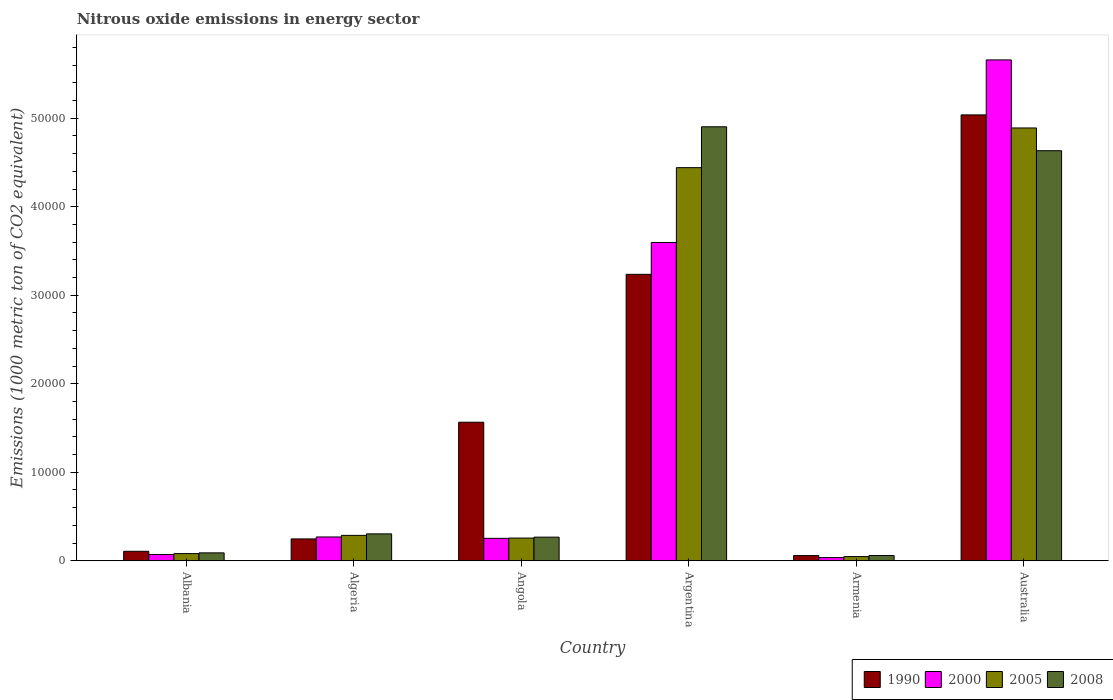How many different coloured bars are there?
Provide a short and direct response. 4. How many groups of bars are there?
Offer a terse response. 6. Are the number of bars per tick equal to the number of legend labels?
Offer a very short reply. Yes. How many bars are there on the 5th tick from the left?
Make the answer very short. 4. What is the label of the 6th group of bars from the left?
Keep it short and to the point. Australia. In how many cases, is the number of bars for a given country not equal to the number of legend labels?
Your answer should be compact. 0. What is the amount of nitrous oxide emitted in 2005 in Algeria?
Keep it short and to the point. 2868.2. Across all countries, what is the maximum amount of nitrous oxide emitted in 2008?
Your answer should be compact. 4.90e+04. Across all countries, what is the minimum amount of nitrous oxide emitted in 2008?
Keep it short and to the point. 593.5. In which country was the amount of nitrous oxide emitted in 2000 maximum?
Offer a very short reply. Australia. In which country was the amount of nitrous oxide emitted in 2000 minimum?
Your answer should be very brief. Armenia. What is the total amount of nitrous oxide emitted in 2005 in the graph?
Your response must be concise. 1.00e+05. What is the difference between the amount of nitrous oxide emitted in 2008 in Angola and that in Australia?
Provide a short and direct response. -4.37e+04. What is the difference between the amount of nitrous oxide emitted in 1990 in Argentina and the amount of nitrous oxide emitted in 2008 in Australia?
Offer a terse response. -1.40e+04. What is the average amount of nitrous oxide emitted in 1990 per country?
Make the answer very short. 1.71e+04. What is the difference between the amount of nitrous oxide emitted of/in 2005 and amount of nitrous oxide emitted of/in 1990 in Albania?
Your response must be concise. -259.9. In how many countries, is the amount of nitrous oxide emitted in 1990 greater than 14000 1000 metric ton?
Your response must be concise. 3. What is the ratio of the amount of nitrous oxide emitted in 1990 in Albania to that in Argentina?
Keep it short and to the point. 0.03. Is the amount of nitrous oxide emitted in 2005 in Algeria less than that in Armenia?
Make the answer very short. No. Is the difference between the amount of nitrous oxide emitted in 2005 in Albania and Australia greater than the difference between the amount of nitrous oxide emitted in 1990 in Albania and Australia?
Keep it short and to the point. Yes. What is the difference between the highest and the second highest amount of nitrous oxide emitted in 2008?
Offer a terse response. -4.60e+04. What is the difference between the highest and the lowest amount of nitrous oxide emitted in 2008?
Your response must be concise. 4.84e+04. What does the 2nd bar from the right in Angola represents?
Provide a succinct answer. 2005. Is it the case that in every country, the sum of the amount of nitrous oxide emitted in 1990 and amount of nitrous oxide emitted in 2008 is greater than the amount of nitrous oxide emitted in 2000?
Your answer should be compact. Yes. How many bars are there?
Provide a succinct answer. 24. How many countries are there in the graph?
Your answer should be compact. 6. Does the graph contain any zero values?
Make the answer very short. No. Does the graph contain grids?
Your answer should be very brief. No. Where does the legend appear in the graph?
Give a very brief answer. Bottom right. How many legend labels are there?
Make the answer very short. 4. How are the legend labels stacked?
Offer a very short reply. Horizontal. What is the title of the graph?
Offer a terse response. Nitrous oxide emissions in energy sector. Does "1987" appear as one of the legend labels in the graph?
Offer a very short reply. No. What is the label or title of the Y-axis?
Give a very brief answer. Emissions (1000 metric ton of CO2 equivalent). What is the Emissions (1000 metric ton of CO2 equivalent) in 1990 in Albania?
Make the answer very short. 1071.9. What is the Emissions (1000 metric ton of CO2 equivalent) in 2000 in Albania?
Keep it short and to the point. 712.1. What is the Emissions (1000 metric ton of CO2 equivalent) of 2005 in Albania?
Your response must be concise. 812. What is the Emissions (1000 metric ton of CO2 equivalent) in 2008 in Albania?
Your answer should be very brief. 894. What is the Emissions (1000 metric ton of CO2 equivalent) in 1990 in Algeria?
Your answer should be compact. 2469.5. What is the Emissions (1000 metric ton of CO2 equivalent) in 2000 in Algeria?
Provide a succinct answer. 2690.4. What is the Emissions (1000 metric ton of CO2 equivalent) of 2005 in Algeria?
Provide a short and direct response. 2868.2. What is the Emissions (1000 metric ton of CO2 equivalent) of 2008 in Algeria?
Your answer should be very brief. 3040.1. What is the Emissions (1000 metric ton of CO2 equivalent) in 1990 in Angola?
Keep it short and to the point. 1.57e+04. What is the Emissions (1000 metric ton of CO2 equivalent) of 2000 in Angola?
Keep it short and to the point. 2535.2. What is the Emissions (1000 metric ton of CO2 equivalent) of 2005 in Angola?
Make the answer very short. 2567.4. What is the Emissions (1000 metric ton of CO2 equivalent) in 2008 in Angola?
Give a very brief answer. 2670.3. What is the Emissions (1000 metric ton of CO2 equivalent) in 1990 in Argentina?
Give a very brief answer. 3.24e+04. What is the Emissions (1000 metric ton of CO2 equivalent) of 2000 in Argentina?
Give a very brief answer. 3.60e+04. What is the Emissions (1000 metric ton of CO2 equivalent) in 2005 in Argentina?
Keep it short and to the point. 4.44e+04. What is the Emissions (1000 metric ton of CO2 equivalent) in 2008 in Argentina?
Your response must be concise. 4.90e+04. What is the Emissions (1000 metric ton of CO2 equivalent) of 1990 in Armenia?
Offer a terse response. 586.2. What is the Emissions (1000 metric ton of CO2 equivalent) of 2000 in Armenia?
Provide a short and direct response. 356.1. What is the Emissions (1000 metric ton of CO2 equivalent) in 2005 in Armenia?
Give a very brief answer. 473.3. What is the Emissions (1000 metric ton of CO2 equivalent) in 2008 in Armenia?
Ensure brevity in your answer.  593.5. What is the Emissions (1000 metric ton of CO2 equivalent) of 1990 in Australia?
Give a very brief answer. 5.04e+04. What is the Emissions (1000 metric ton of CO2 equivalent) in 2000 in Australia?
Keep it short and to the point. 5.66e+04. What is the Emissions (1000 metric ton of CO2 equivalent) in 2005 in Australia?
Ensure brevity in your answer.  4.89e+04. What is the Emissions (1000 metric ton of CO2 equivalent) of 2008 in Australia?
Make the answer very short. 4.63e+04. Across all countries, what is the maximum Emissions (1000 metric ton of CO2 equivalent) of 1990?
Offer a terse response. 5.04e+04. Across all countries, what is the maximum Emissions (1000 metric ton of CO2 equivalent) of 2000?
Your response must be concise. 5.66e+04. Across all countries, what is the maximum Emissions (1000 metric ton of CO2 equivalent) of 2005?
Make the answer very short. 4.89e+04. Across all countries, what is the maximum Emissions (1000 metric ton of CO2 equivalent) in 2008?
Offer a terse response. 4.90e+04. Across all countries, what is the minimum Emissions (1000 metric ton of CO2 equivalent) of 1990?
Your response must be concise. 586.2. Across all countries, what is the minimum Emissions (1000 metric ton of CO2 equivalent) in 2000?
Keep it short and to the point. 356.1. Across all countries, what is the minimum Emissions (1000 metric ton of CO2 equivalent) of 2005?
Offer a terse response. 473.3. Across all countries, what is the minimum Emissions (1000 metric ton of CO2 equivalent) of 2008?
Provide a short and direct response. 593.5. What is the total Emissions (1000 metric ton of CO2 equivalent) in 1990 in the graph?
Ensure brevity in your answer.  1.03e+05. What is the total Emissions (1000 metric ton of CO2 equivalent) of 2000 in the graph?
Provide a succinct answer. 9.88e+04. What is the total Emissions (1000 metric ton of CO2 equivalent) in 2005 in the graph?
Your answer should be compact. 1.00e+05. What is the total Emissions (1000 metric ton of CO2 equivalent) in 2008 in the graph?
Your response must be concise. 1.03e+05. What is the difference between the Emissions (1000 metric ton of CO2 equivalent) in 1990 in Albania and that in Algeria?
Give a very brief answer. -1397.6. What is the difference between the Emissions (1000 metric ton of CO2 equivalent) in 2000 in Albania and that in Algeria?
Your answer should be very brief. -1978.3. What is the difference between the Emissions (1000 metric ton of CO2 equivalent) of 2005 in Albania and that in Algeria?
Ensure brevity in your answer.  -2056.2. What is the difference between the Emissions (1000 metric ton of CO2 equivalent) in 2008 in Albania and that in Algeria?
Give a very brief answer. -2146.1. What is the difference between the Emissions (1000 metric ton of CO2 equivalent) of 1990 in Albania and that in Angola?
Make the answer very short. -1.46e+04. What is the difference between the Emissions (1000 metric ton of CO2 equivalent) in 2000 in Albania and that in Angola?
Give a very brief answer. -1823.1. What is the difference between the Emissions (1000 metric ton of CO2 equivalent) of 2005 in Albania and that in Angola?
Offer a terse response. -1755.4. What is the difference between the Emissions (1000 metric ton of CO2 equivalent) in 2008 in Albania and that in Angola?
Your answer should be very brief. -1776.3. What is the difference between the Emissions (1000 metric ton of CO2 equivalent) in 1990 in Albania and that in Argentina?
Your answer should be very brief. -3.13e+04. What is the difference between the Emissions (1000 metric ton of CO2 equivalent) in 2000 in Albania and that in Argentina?
Your answer should be very brief. -3.53e+04. What is the difference between the Emissions (1000 metric ton of CO2 equivalent) in 2005 in Albania and that in Argentina?
Offer a terse response. -4.36e+04. What is the difference between the Emissions (1000 metric ton of CO2 equivalent) in 2008 in Albania and that in Argentina?
Offer a very short reply. -4.81e+04. What is the difference between the Emissions (1000 metric ton of CO2 equivalent) in 1990 in Albania and that in Armenia?
Your answer should be very brief. 485.7. What is the difference between the Emissions (1000 metric ton of CO2 equivalent) in 2000 in Albania and that in Armenia?
Your answer should be very brief. 356. What is the difference between the Emissions (1000 metric ton of CO2 equivalent) in 2005 in Albania and that in Armenia?
Offer a very short reply. 338.7. What is the difference between the Emissions (1000 metric ton of CO2 equivalent) of 2008 in Albania and that in Armenia?
Offer a terse response. 300.5. What is the difference between the Emissions (1000 metric ton of CO2 equivalent) of 1990 in Albania and that in Australia?
Ensure brevity in your answer.  -4.93e+04. What is the difference between the Emissions (1000 metric ton of CO2 equivalent) of 2000 in Albania and that in Australia?
Provide a succinct answer. -5.59e+04. What is the difference between the Emissions (1000 metric ton of CO2 equivalent) in 2005 in Albania and that in Australia?
Offer a very short reply. -4.81e+04. What is the difference between the Emissions (1000 metric ton of CO2 equivalent) in 2008 in Albania and that in Australia?
Provide a short and direct response. -4.54e+04. What is the difference between the Emissions (1000 metric ton of CO2 equivalent) in 1990 in Algeria and that in Angola?
Your answer should be compact. -1.32e+04. What is the difference between the Emissions (1000 metric ton of CO2 equivalent) of 2000 in Algeria and that in Angola?
Give a very brief answer. 155.2. What is the difference between the Emissions (1000 metric ton of CO2 equivalent) of 2005 in Algeria and that in Angola?
Offer a very short reply. 300.8. What is the difference between the Emissions (1000 metric ton of CO2 equivalent) in 2008 in Algeria and that in Angola?
Offer a terse response. 369.8. What is the difference between the Emissions (1000 metric ton of CO2 equivalent) in 1990 in Algeria and that in Argentina?
Offer a very short reply. -2.99e+04. What is the difference between the Emissions (1000 metric ton of CO2 equivalent) in 2000 in Algeria and that in Argentina?
Provide a short and direct response. -3.33e+04. What is the difference between the Emissions (1000 metric ton of CO2 equivalent) of 2005 in Algeria and that in Argentina?
Your answer should be very brief. -4.15e+04. What is the difference between the Emissions (1000 metric ton of CO2 equivalent) of 2008 in Algeria and that in Argentina?
Ensure brevity in your answer.  -4.60e+04. What is the difference between the Emissions (1000 metric ton of CO2 equivalent) of 1990 in Algeria and that in Armenia?
Your answer should be compact. 1883.3. What is the difference between the Emissions (1000 metric ton of CO2 equivalent) in 2000 in Algeria and that in Armenia?
Offer a very short reply. 2334.3. What is the difference between the Emissions (1000 metric ton of CO2 equivalent) of 2005 in Algeria and that in Armenia?
Offer a very short reply. 2394.9. What is the difference between the Emissions (1000 metric ton of CO2 equivalent) in 2008 in Algeria and that in Armenia?
Ensure brevity in your answer.  2446.6. What is the difference between the Emissions (1000 metric ton of CO2 equivalent) in 1990 in Algeria and that in Australia?
Your answer should be very brief. -4.79e+04. What is the difference between the Emissions (1000 metric ton of CO2 equivalent) in 2000 in Algeria and that in Australia?
Keep it short and to the point. -5.39e+04. What is the difference between the Emissions (1000 metric ton of CO2 equivalent) in 2005 in Algeria and that in Australia?
Keep it short and to the point. -4.60e+04. What is the difference between the Emissions (1000 metric ton of CO2 equivalent) of 2008 in Algeria and that in Australia?
Provide a short and direct response. -4.33e+04. What is the difference between the Emissions (1000 metric ton of CO2 equivalent) in 1990 in Angola and that in Argentina?
Provide a short and direct response. -1.67e+04. What is the difference between the Emissions (1000 metric ton of CO2 equivalent) in 2000 in Angola and that in Argentina?
Give a very brief answer. -3.34e+04. What is the difference between the Emissions (1000 metric ton of CO2 equivalent) of 2005 in Angola and that in Argentina?
Offer a very short reply. -4.18e+04. What is the difference between the Emissions (1000 metric ton of CO2 equivalent) of 2008 in Angola and that in Argentina?
Offer a very short reply. -4.64e+04. What is the difference between the Emissions (1000 metric ton of CO2 equivalent) of 1990 in Angola and that in Armenia?
Your answer should be compact. 1.51e+04. What is the difference between the Emissions (1000 metric ton of CO2 equivalent) of 2000 in Angola and that in Armenia?
Your answer should be compact. 2179.1. What is the difference between the Emissions (1000 metric ton of CO2 equivalent) of 2005 in Angola and that in Armenia?
Your response must be concise. 2094.1. What is the difference between the Emissions (1000 metric ton of CO2 equivalent) of 2008 in Angola and that in Armenia?
Your answer should be very brief. 2076.8. What is the difference between the Emissions (1000 metric ton of CO2 equivalent) of 1990 in Angola and that in Australia?
Your answer should be compact. -3.47e+04. What is the difference between the Emissions (1000 metric ton of CO2 equivalent) of 2000 in Angola and that in Australia?
Provide a short and direct response. -5.41e+04. What is the difference between the Emissions (1000 metric ton of CO2 equivalent) of 2005 in Angola and that in Australia?
Offer a very short reply. -4.63e+04. What is the difference between the Emissions (1000 metric ton of CO2 equivalent) in 2008 in Angola and that in Australia?
Ensure brevity in your answer.  -4.37e+04. What is the difference between the Emissions (1000 metric ton of CO2 equivalent) in 1990 in Argentina and that in Armenia?
Provide a short and direct response. 3.18e+04. What is the difference between the Emissions (1000 metric ton of CO2 equivalent) in 2000 in Argentina and that in Armenia?
Give a very brief answer. 3.56e+04. What is the difference between the Emissions (1000 metric ton of CO2 equivalent) of 2005 in Argentina and that in Armenia?
Make the answer very short. 4.39e+04. What is the difference between the Emissions (1000 metric ton of CO2 equivalent) in 2008 in Argentina and that in Armenia?
Your answer should be compact. 4.84e+04. What is the difference between the Emissions (1000 metric ton of CO2 equivalent) of 1990 in Argentina and that in Australia?
Your response must be concise. -1.80e+04. What is the difference between the Emissions (1000 metric ton of CO2 equivalent) in 2000 in Argentina and that in Australia?
Make the answer very short. -2.06e+04. What is the difference between the Emissions (1000 metric ton of CO2 equivalent) in 2005 in Argentina and that in Australia?
Give a very brief answer. -4485.6. What is the difference between the Emissions (1000 metric ton of CO2 equivalent) in 2008 in Argentina and that in Australia?
Offer a very short reply. 2702.4. What is the difference between the Emissions (1000 metric ton of CO2 equivalent) in 1990 in Armenia and that in Australia?
Keep it short and to the point. -4.98e+04. What is the difference between the Emissions (1000 metric ton of CO2 equivalent) of 2000 in Armenia and that in Australia?
Provide a succinct answer. -5.62e+04. What is the difference between the Emissions (1000 metric ton of CO2 equivalent) of 2005 in Armenia and that in Australia?
Your answer should be very brief. -4.84e+04. What is the difference between the Emissions (1000 metric ton of CO2 equivalent) in 2008 in Armenia and that in Australia?
Ensure brevity in your answer.  -4.57e+04. What is the difference between the Emissions (1000 metric ton of CO2 equivalent) in 1990 in Albania and the Emissions (1000 metric ton of CO2 equivalent) in 2000 in Algeria?
Your response must be concise. -1618.5. What is the difference between the Emissions (1000 metric ton of CO2 equivalent) in 1990 in Albania and the Emissions (1000 metric ton of CO2 equivalent) in 2005 in Algeria?
Offer a terse response. -1796.3. What is the difference between the Emissions (1000 metric ton of CO2 equivalent) of 1990 in Albania and the Emissions (1000 metric ton of CO2 equivalent) of 2008 in Algeria?
Your answer should be very brief. -1968.2. What is the difference between the Emissions (1000 metric ton of CO2 equivalent) of 2000 in Albania and the Emissions (1000 metric ton of CO2 equivalent) of 2005 in Algeria?
Provide a short and direct response. -2156.1. What is the difference between the Emissions (1000 metric ton of CO2 equivalent) of 2000 in Albania and the Emissions (1000 metric ton of CO2 equivalent) of 2008 in Algeria?
Make the answer very short. -2328. What is the difference between the Emissions (1000 metric ton of CO2 equivalent) in 2005 in Albania and the Emissions (1000 metric ton of CO2 equivalent) in 2008 in Algeria?
Keep it short and to the point. -2228.1. What is the difference between the Emissions (1000 metric ton of CO2 equivalent) of 1990 in Albania and the Emissions (1000 metric ton of CO2 equivalent) of 2000 in Angola?
Make the answer very short. -1463.3. What is the difference between the Emissions (1000 metric ton of CO2 equivalent) of 1990 in Albania and the Emissions (1000 metric ton of CO2 equivalent) of 2005 in Angola?
Ensure brevity in your answer.  -1495.5. What is the difference between the Emissions (1000 metric ton of CO2 equivalent) in 1990 in Albania and the Emissions (1000 metric ton of CO2 equivalent) in 2008 in Angola?
Offer a very short reply. -1598.4. What is the difference between the Emissions (1000 metric ton of CO2 equivalent) of 2000 in Albania and the Emissions (1000 metric ton of CO2 equivalent) of 2005 in Angola?
Your answer should be very brief. -1855.3. What is the difference between the Emissions (1000 metric ton of CO2 equivalent) in 2000 in Albania and the Emissions (1000 metric ton of CO2 equivalent) in 2008 in Angola?
Provide a short and direct response. -1958.2. What is the difference between the Emissions (1000 metric ton of CO2 equivalent) of 2005 in Albania and the Emissions (1000 metric ton of CO2 equivalent) of 2008 in Angola?
Make the answer very short. -1858.3. What is the difference between the Emissions (1000 metric ton of CO2 equivalent) in 1990 in Albania and the Emissions (1000 metric ton of CO2 equivalent) in 2000 in Argentina?
Provide a succinct answer. -3.49e+04. What is the difference between the Emissions (1000 metric ton of CO2 equivalent) in 1990 in Albania and the Emissions (1000 metric ton of CO2 equivalent) in 2005 in Argentina?
Offer a very short reply. -4.33e+04. What is the difference between the Emissions (1000 metric ton of CO2 equivalent) of 1990 in Albania and the Emissions (1000 metric ton of CO2 equivalent) of 2008 in Argentina?
Your answer should be compact. -4.80e+04. What is the difference between the Emissions (1000 metric ton of CO2 equivalent) of 2000 in Albania and the Emissions (1000 metric ton of CO2 equivalent) of 2005 in Argentina?
Give a very brief answer. -4.37e+04. What is the difference between the Emissions (1000 metric ton of CO2 equivalent) of 2000 in Albania and the Emissions (1000 metric ton of CO2 equivalent) of 2008 in Argentina?
Your answer should be very brief. -4.83e+04. What is the difference between the Emissions (1000 metric ton of CO2 equivalent) in 2005 in Albania and the Emissions (1000 metric ton of CO2 equivalent) in 2008 in Argentina?
Provide a succinct answer. -4.82e+04. What is the difference between the Emissions (1000 metric ton of CO2 equivalent) of 1990 in Albania and the Emissions (1000 metric ton of CO2 equivalent) of 2000 in Armenia?
Offer a terse response. 715.8. What is the difference between the Emissions (1000 metric ton of CO2 equivalent) of 1990 in Albania and the Emissions (1000 metric ton of CO2 equivalent) of 2005 in Armenia?
Your response must be concise. 598.6. What is the difference between the Emissions (1000 metric ton of CO2 equivalent) of 1990 in Albania and the Emissions (1000 metric ton of CO2 equivalent) of 2008 in Armenia?
Keep it short and to the point. 478.4. What is the difference between the Emissions (1000 metric ton of CO2 equivalent) in 2000 in Albania and the Emissions (1000 metric ton of CO2 equivalent) in 2005 in Armenia?
Provide a succinct answer. 238.8. What is the difference between the Emissions (1000 metric ton of CO2 equivalent) in 2000 in Albania and the Emissions (1000 metric ton of CO2 equivalent) in 2008 in Armenia?
Offer a terse response. 118.6. What is the difference between the Emissions (1000 metric ton of CO2 equivalent) of 2005 in Albania and the Emissions (1000 metric ton of CO2 equivalent) of 2008 in Armenia?
Ensure brevity in your answer.  218.5. What is the difference between the Emissions (1000 metric ton of CO2 equivalent) in 1990 in Albania and the Emissions (1000 metric ton of CO2 equivalent) in 2000 in Australia?
Offer a very short reply. -5.55e+04. What is the difference between the Emissions (1000 metric ton of CO2 equivalent) of 1990 in Albania and the Emissions (1000 metric ton of CO2 equivalent) of 2005 in Australia?
Make the answer very short. -4.78e+04. What is the difference between the Emissions (1000 metric ton of CO2 equivalent) in 1990 in Albania and the Emissions (1000 metric ton of CO2 equivalent) in 2008 in Australia?
Your response must be concise. -4.53e+04. What is the difference between the Emissions (1000 metric ton of CO2 equivalent) of 2000 in Albania and the Emissions (1000 metric ton of CO2 equivalent) of 2005 in Australia?
Keep it short and to the point. -4.82e+04. What is the difference between the Emissions (1000 metric ton of CO2 equivalent) of 2000 in Albania and the Emissions (1000 metric ton of CO2 equivalent) of 2008 in Australia?
Your answer should be compact. -4.56e+04. What is the difference between the Emissions (1000 metric ton of CO2 equivalent) of 2005 in Albania and the Emissions (1000 metric ton of CO2 equivalent) of 2008 in Australia?
Provide a short and direct response. -4.55e+04. What is the difference between the Emissions (1000 metric ton of CO2 equivalent) in 1990 in Algeria and the Emissions (1000 metric ton of CO2 equivalent) in 2000 in Angola?
Offer a very short reply. -65.7. What is the difference between the Emissions (1000 metric ton of CO2 equivalent) of 1990 in Algeria and the Emissions (1000 metric ton of CO2 equivalent) of 2005 in Angola?
Provide a succinct answer. -97.9. What is the difference between the Emissions (1000 metric ton of CO2 equivalent) in 1990 in Algeria and the Emissions (1000 metric ton of CO2 equivalent) in 2008 in Angola?
Provide a short and direct response. -200.8. What is the difference between the Emissions (1000 metric ton of CO2 equivalent) of 2000 in Algeria and the Emissions (1000 metric ton of CO2 equivalent) of 2005 in Angola?
Your answer should be compact. 123. What is the difference between the Emissions (1000 metric ton of CO2 equivalent) of 2000 in Algeria and the Emissions (1000 metric ton of CO2 equivalent) of 2008 in Angola?
Offer a very short reply. 20.1. What is the difference between the Emissions (1000 metric ton of CO2 equivalent) of 2005 in Algeria and the Emissions (1000 metric ton of CO2 equivalent) of 2008 in Angola?
Ensure brevity in your answer.  197.9. What is the difference between the Emissions (1000 metric ton of CO2 equivalent) in 1990 in Algeria and the Emissions (1000 metric ton of CO2 equivalent) in 2000 in Argentina?
Your response must be concise. -3.35e+04. What is the difference between the Emissions (1000 metric ton of CO2 equivalent) of 1990 in Algeria and the Emissions (1000 metric ton of CO2 equivalent) of 2005 in Argentina?
Offer a terse response. -4.19e+04. What is the difference between the Emissions (1000 metric ton of CO2 equivalent) in 1990 in Algeria and the Emissions (1000 metric ton of CO2 equivalent) in 2008 in Argentina?
Ensure brevity in your answer.  -4.66e+04. What is the difference between the Emissions (1000 metric ton of CO2 equivalent) in 2000 in Algeria and the Emissions (1000 metric ton of CO2 equivalent) in 2005 in Argentina?
Provide a succinct answer. -4.17e+04. What is the difference between the Emissions (1000 metric ton of CO2 equivalent) in 2000 in Algeria and the Emissions (1000 metric ton of CO2 equivalent) in 2008 in Argentina?
Your response must be concise. -4.63e+04. What is the difference between the Emissions (1000 metric ton of CO2 equivalent) of 2005 in Algeria and the Emissions (1000 metric ton of CO2 equivalent) of 2008 in Argentina?
Offer a terse response. -4.62e+04. What is the difference between the Emissions (1000 metric ton of CO2 equivalent) of 1990 in Algeria and the Emissions (1000 metric ton of CO2 equivalent) of 2000 in Armenia?
Give a very brief answer. 2113.4. What is the difference between the Emissions (1000 metric ton of CO2 equivalent) of 1990 in Algeria and the Emissions (1000 metric ton of CO2 equivalent) of 2005 in Armenia?
Offer a very short reply. 1996.2. What is the difference between the Emissions (1000 metric ton of CO2 equivalent) of 1990 in Algeria and the Emissions (1000 metric ton of CO2 equivalent) of 2008 in Armenia?
Keep it short and to the point. 1876. What is the difference between the Emissions (1000 metric ton of CO2 equivalent) of 2000 in Algeria and the Emissions (1000 metric ton of CO2 equivalent) of 2005 in Armenia?
Your answer should be compact. 2217.1. What is the difference between the Emissions (1000 metric ton of CO2 equivalent) in 2000 in Algeria and the Emissions (1000 metric ton of CO2 equivalent) in 2008 in Armenia?
Provide a succinct answer. 2096.9. What is the difference between the Emissions (1000 metric ton of CO2 equivalent) in 2005 in Algeria and the Emissions (1000 metric ton of CO2 equivalent) in 2008 in Armenia?
Your answer should be very brief. 2274.7. What is the difference between the Emissions (1000 metric ton of CO2 equivalent) of 1990 in Algeria and the Emissions (1000 metric ton of CO2 equivalent) of 2000 in Australia?
Ensure brevity in your answer.  -5.41e+04. What is the difference between the Emissions (1000 metric ton of CO2 equivalent) of 1990 in Algeria and the Emissions (1000 metric ton of CO2 equivalent) of 2005 in Australia?
Give a very brief answer. -4.64e+04. What is the difference between the Emissions (1000 metric ton of CO2 equivalent) in 1990 in Algeria and the Emissions (1000 metric ton of CO2 equivalent) in 2008 in Australia?
Your answer should be very brief. -4.39e+04. What is the difference between the Emissions (1000 metric ton of CO2 equivalent) of 2000 in Algeria and the Emissions (1000 metric ton of CO2 equivalent) of 2005 in Australia?
Provide a short and direct response. -4.62e+04. What is the difference between the Emissions (1000 metric ton of CO2 equivalent) of 2000 in Algeria and the Emissions (1000 metric ton of CO2 equivalent) of 2008 in Australia?
Provide a short and direct response. -4.36e+04. What is the difference between the Emissions (1000 metric ton of CO2 equivalent) of 2005 in Algeria and the Emissions (1000 metric ton of CO2 equivalent) of 2008 in Australia?
Your answer should be compact. -4.35e+04. What is the difference between the Emissions (1000 metric ton of CO2 equivalent) in 1990 in Angola and the Emissions (1000 metric ton of CO2 equivalent) in 2000 in Argentina?
Offer a very short reply. -2.03e+04. What is the difference between the Emissions (1000 metric ton of CO2 equivalent) of 1990 in Angola and the Emissions (1000 metric ton of CO2 equivalent) of 2005 in Argentina?
Provide a short and direct response. -2.88e+04. What is the difference between the Emissions (1000 metric ton of CO2 equivalent) in 1990 in Angola and the Emissions (1000 metric ton of CO2 equivalent) in 2008 in Argentina?
Offer a very short reply. -3.34e+04. What is the difference between the Emissions (1000 metric ton of CO2 equivalent) of 2000 in Angola and the Emissions (1000 metric ton of CO2 equivalent) of 2005 in Argentina?
Keep it short and to the point. -4.19e+04. What is the difference between the Emissions (1000 metric ton of CO2 equivalent) in 2000 in Angola and the Emissions (1000 metric ton of CO2 equivalent) in 2008 in Argentina?
Keep it short and to the point. -4.65e+04. What is the difference between the Emissions (1000 metric ton of CO2 equivalent) of 2005 in Angola and the Emissions (1000 metric ton of CO2 equivalent) of 2008 in Argentina?
Your answer should be very brief. -4.65e+04. What is the difference between the Emissions (1000 metric ton of CO2 equivalent) in 1990 in Angola and the Emissions (1000 metric ton of CO2 equivalent) in 2000 in Armenia?
Keep it short and to the point. 1.53e+04. What is the difference between the Emissions (1000 metric ton of CO2 equivalent) of 1990 in Angola and the Emissions (1000 metric ton of CO2 equivalent) of 2005 in Armenia?
Offer a terse response. 1.52e+04. What is the difference between the Emissions (1000 metric ton of CO2 equivalent) of 1990 in Angola and the Emissions (1000 metric ton of CO2 equivalent) of 2008 in Armenia?
Give a very brief answer. 1.51e+04. What is the difference between the Emissions (1000 metric ton of CO2 equivalent) in 2000 in Angola and the Emissions (1000 metric ton of CO2 equivalent) in 2005 in Armenia?
Offer a terse response. 2061.9. What is the difference between the Emissions (1000 metric ton of CO2 equivalent) in 2000 in Angola and the Emissions (1000 metric ton of CO2 equivalent) in 2008 in Armenia?
Keep it short and to the point. 1941.7. What is the difference between the Emissions (1000 metric ton of CO2 equivalent) of 2005 in Angola and the Emissions (1000 metric ton of CO2 equivalent) of 2008 in Armenia?
Provide a succinct answer. 1973.9. What is the difference between the Emissions (1000 metric ton of CO2 equivalent) in 1990 in Angola and the Emissions (1000 metric ton of CO2 equivalent) in 2000 in Australia?
Make the answer very short. -4.09e+04. What is the difference between the Emissions (1000 metric ton of CO2 equivalent) in 1990 in Angola and the Emissions (1000 metric ton of CO2 equivalent) in 2005 in Australia?
Provide a succinct answer. -3.32e+04. What is the difference between the Emissions (1000 metric ton of CO2 equivalent) of 1990 in Angola and the Emissions (1000 metric ton of CO2 equivalent) of 2008 in Australia?
Your answer should be very brief. -3.07e+04. What is the difference between the Emissions (1000 metric ton of CO2 equivalent) in 2000 in Angola and the Emissions (1000 metric ton of CO2 equivalent) in 2005 in Australia?
Offer a terse response. -4.64e+04. What is the difference between the Emissions (1000 metric ton of CO2 equivalent) of 2000 in Angola and the Emissions (1000 metric ton of CO2 equivalent) of 2008 in Australia?
Your answer should be compact. -4.38e+04. What is the difference between the Emissions (1000 metric ton of CO2 equivalent) in 2005 in Angola and the Emissions (1000 metric ton of CO2 equivalent) in 2008 in Australia?
Keep it short and to the point. -4.38e+04. What is the difference between the Emissions (1000 metric ton of CO2 equivalent) in 1990 in Argentina and the Emissions (1000 metric ton of CO2 equivalent) in 2000 in Armenia?
Offer a very short reply. 3.20e+04. What is the difference between the Emissions (1000 metric ton of CO2 equivalent) in 1990 in Argentina and the Emissions (1000 metric ton of CO2 equivalent) in 2005 in Armenia?
Your response must be concise. 3.19e+04. What is the difference between the Emissions (1000 metric ton of CO2 equivalent) of 1990 in Argentina and the Emissions (1000 metric ton of CO2 equivalent) of 2008 in Armenia?
Offer a very short reply. 3.18e+04. What is the difference between the Emissions (1000 metric ton of CO2 equivalent) in 2000 in Argentina and the Emissions (1000 metric ton of CO2 equivalent) in 2005 in Armenia?
Offer a very short reply. 3.55e+04. What is the difference between the Emissions (1000 metric ton of CO2 equivalent) of 2000 in Argentina and the Emissions (1000 metric ton of CO2 equivalent) of 2008 in Armenia?
Offer a very short reply. 3.54e+04. What is the difference between the Emissions (1000 metric ton of CO2 equivalent) of 2005 in Argentina and the Emissions (1000 metric ton of CO2 equivalent) of 2008 in Armenia?
Make the answer very short. 4.38e+04. What is the difference between the Emissions (1000 metric ton of CO2 equivalent) of 1990 in Argentina and the Emissions (1000 metric ton of CO2 equivalent) of 2000 in Australia?
Make the answer very short. -2.42e+04. What is the difference between the Emissions (1000 metric ton of CO2 equivalent) of 1990 in Argentina and the Emissions (1000 metric ton of CO2 equivalent) of 2005 in Australia?
Your answer should be very brief. -1.65e+04. What is the difference between the Emissions (1000 metric ton of CO2 equivalent) in 1990 in Argentina and the Emissions (1000 metric ton of CO2 equivalent) in 2008 in Australia?
Provide a succinct answer. -1.40e+04. What is the difference between the Emissions (1000 metric ton of CO2 equivalent) of 2000 in Argentina and the Emissions (1000 metric ton of CO2 equivalent) of 2005 in Australia?
Give a very brief answer. -1.29e+04. What is the difference between the Emissions (1000 metric ton of CO2 equivalent) of 2000 in Argentina and the Emissions (1000 metric ton of CO2 equivalent) of 2008 in Australia?
Keep it short and to the point. -1.04e+04. What is the difference between the Emissions (1000 metric ton of CO2 equivalent) of 2005 in Argentina and the Emissions (1000 metric ton of CO2 equivalent) of 2008 in Australia?
Give a very brief answer. -1915.3. What is the difference between the Emissions (1000 metric ton of CO2 equivalent) in 1990 in Armenia and the Emissions (1000 metric ton of CO2 equivalent) in 2000 in Australia?
Provide a short and direct response. -5.60e+04. What is the difference between the Emissions (1000 metric ton of CO2 equivalent) of 1990 in Armenia and the Emissions (1000 metric ton of CO2 equivalent) of 2005 in Australia?
Make the answer very short. -4.83e+04. What is the difference between the Emissions (1000 metric ton of CO2 equivalent) in 1990 in Armenia and the Emissions (1000 metric ton of CO2 equivalent) in 2008 in Australia?
Offer a very short reply. -4.57e+04. What is the difference between the Emissions (1000 metric ton of CO2 equivalent) in 2000 in Armenia and the Emissions (1000 metric ton of CO2 equivalent) in 2005 in Australia?
Give a very brief answer. -4.85e+04. What is the difference between the Emissions (1000 metric ton of CO2 equivalent) in 2000 in Armenia and the Emissions (1000 metric ton of CO2 equivalent) in 2008 in Australia?
Your answer should be very brief. -4.60e+04. What is the difference between the Emissions (1000 metric ton of CO2 equivalent) in 2005 in Armenia and the Emissions (1000 metric ton of CO2 equivalent) in 2008 in Australia?
Provide a short and direct response. -4.59e+04. What is the average Emissions (1000 metric ton of CO2 equivalent) of 1990 per country?
Keep it short and to the point. 1.71e+04. What is the average Emissions (1000 metric ton of CO2 equivalent) of 2000 per country?
Offer a very short reply. 1.65e+04. What is the average Emissions (1000 metric ton of CO2 equivalent) of 2005 per country?
Your answer should be very brief. 1.67e+04. What is the average Emissions (1000 metric ton of CO2 equivalent) in 2008 per country?
Make the answer very short. 1.71e+04. What is the difference between the Emissions (1000 metric ton of CO2 equivalent) of 1990 and Emissions (1000 metric ton of CO2 equivalent) of 2000 in Albania?
Offer a very short reply. 359.8. What is the difference between the Emissions (1000 metric ton of CO2 equivalent) in 1990 and Emissions (1000 metric ton of CO2 equivalent) in 2005 in Albania?
Provide a short and direct response. 259.9. What is the difference between the Emissions (1000 metric ton of CO2 equivalent) in 1990 and Emissions (1000 metric ton of CO2 equivalent) in 2008 in Albania?
Your answer should be very brief. 177.9. What is the difference between the Emissions (1000 metric ton of CO2 equivalent) of 2000 and Emissions (1000 metric ton of CO2 equivalent) of 2005 in Albania?
Offer a terse response. -99.9. What is the difference between the Emissions (1000 metric ton of CO2 equivalent) of 2000 and Emissions (1000 metric ton of CO2 equivalent) of 2008 in Albania?
Ensure brevity in your answer.  -181.9. What is the difference between the Emissions (1000 metric ton of CO2 equivalent) in 2005 and Emissions (1000 metric ton of CO2 equivalent) in 2008 in Albania?
Keep it short and to the point. -82. What is the difference between the Emissions (1000 metric ton of CO2 equivalent) of 1990 and Emissions (1000 metric ton of CO2 equivalent) of 2000 in Algeria?
Make the answer very short. -220.9. What is the difference between the Emissions (1000 metric ton of CO2 equivalent) in 1990 and Emissions (1000 metric ton of CO2 equivalent) in 2005 in Algeria?
Offer a very short reply. -398.7. What is the difference between the Emissions (1000 metric ton of CO2 equivalent) of 1990 and Emissions (1000 metric ton of CO2 equivalent) of 2008 in Algeria?
Make the answer very short. -570.6. What is the difference between the Emissions (1000 metric ton of CO2 equivalent) in 2000 and Emissions (1000 metric ton of CO2 equivalent) in 2005 in Algeria?
Your answer should be compact. -177.8. What is the difference between the Emissions (1000 metric ton of CO2 equivalent) in 2000 and Emissions (1000 metric ton of CO2 equivalent) in 2008 in Algeria?
Your answer should be compact. -349.7. What is the difference between the Emissions (1000 metric ton of CO2 equivalent) of 2005 and Emissions (1000 metric ton of CO2 equivalent) of 2008 in Algeria?
Your answer should be compact. -171.9. What is the difference between the Emissions (1000 metric ton of CO2 equivalent) of 1990 and Emissions (1000 metric ton of CO2 equivalent) of 2000 in Angola?
Offer a terse response. 1.31e+04. What is the difference between the Emissions (1000 metric ton of CO2 equivalent) of 1990 and Emissions (1000 metric ton of CO2 equivalent) of 2005 in Angola?
Provide a succinct answer. 1.31e+04. What is the difference between the Emissions (1000 metric ton of CO2 equivalent) in 1990 and Emissions (1000 metric ton of CO2 equivalent) in 2008 in Angola?
Provide a succinct answer. 1.30e+04. What is the difference between the Emissions (1000 metric ton of CO2 equivalent) in 2000 and Emissions (1000 metric ton of CO2 equivalent) in 2005 in Angola?
Your answer should be compact. -32.2. What is the difference between the Emissions (1000 metric ton of CO2 equivalent) of 2000 and Emissions (1000 metric ton of CO2 equivalent) of 2008 in Angola?
Provide a short and direct response. -135.1. What is the difference between the Emissions (1000 metric ton of CO2 equivalent) in 2005 and Emissions (1000 metric ton of CO2 equivalent) in 2008 in Angola?
Ensure brevity in your answer.  -102.9. What is the difference between the Emissions (1000 metric ton of CO2 equivalent) in 1990 and Emissions (1000 metric ton of CO2 equivalent) in 2000 in Argentina?
Offer a terse response. -3600.5. What is the difference between the Emissions (1000 metric ton of CO2 equivalent) in 1990 and Emissions (1000 metric ton of CO2 equivalent) in 2005 in Argentina?
Your answer should be compact. -1.21e+04. What is the difference between the Emissions (1000 metric ton of CO2 equivalent) in 1990 and Emissions (1000 metric ton of CO2 equivalent) in 2008 in Argentina?
Offer a very short reply. -1.67e+04. What is the difference between the Emissions (1000 metric ton of CO2 equivalent) of 2000 and Emissions (1000 metric ton of CO2 equivalent) of 2005 in Argentina?
Keep it short and to the point. -8453.1. What is the difference between the Emissions (1000 metric ton of CO2 equivalent) of 2000 and Emissions (1000 metric ton of CO2 equivalent) of 2008 in Argentina?
Keep it short and to the point. -1.31e+04. What is the difference between the Emissions (1000 metric ton of CO2 equivalent) in 2005 and Emissions (1000 metric ton of CO2 equivalent) in 2008 in Argentina?
Provide a short and direct response. -4617.7. What is the difference between the Emissions (1000 metric ton of CO2 equivalent) in 1990 and Emissions (1000 metric ton of CO2 equivalent) in 2000 in Armenia?
Your answer should be very brief. 230.1. What is the difference between the Emissions (1000 metric ton of CO2 equivalent) in 1990 and Emissions (1000 metric ton of CO2 equivalent) in 2005 in Armenia?
Give a very brief answer. 112.9. What is the difference between the Emissions (1000 metric ton of CO2 equivalent) of 1990 and Emissions (1000 metric ton of CO2 equivalent) of 2008 in Armenia?
Your answer should be very brief. -7.3. What is the difference between the Emissions (1000 metric ton of CO2 equivalent) of 2000 and Emissions (1000 metric ton of CO2 equivalent) of 2005 in Armenia?
Provide a short and direct response. -117.2. What is the difference between the Emissions (1000 metric ton of CO2 equivalent) in 2000 and Emissions (1000 metric ton of CO2 equivalent) in 2008 in Armenia?
Your response must be concise. -237.4. What is the difference between the Emissions (1000 metric ton of CO2 equivalent) of 2005 and Emissions (1000 metric ton of CO2 equivalent) of 2008 in Armenia?
Provide a succinct answer. -120.2. What is the difference between the Emissions (1000 metric ton of CO2 equivalent) of 1990 and Emissions (1000 metric ton of CO2 equivalent) of 2000 in Australia?
Your response must be concise. -6212.8. What is the difference between the Emissions (1000 metric ton of CO2 equivalent) of 1990 and Emissions (1000 metric ton of CO2 equivalent) of 2005 in Australia?
Give a very brief answer. 1475.2. What is the difference between the Emissions (1000 metric ton of CO2 equivalent) of 1990 and Emissions (1000 metric ton of CO2 equivalent) of 2008 in Australia?
Provide a short and direct response. 4045.5. What is the difference between the Emissions (1000 metric ton of CO2 equivalent) in 2000 and Emissions (1000 metric ton of CO2 equivalent) in 2005 in Australia?
Provide a succinct answer. 7688. What is the difference between the Emissions (1000 metric ton of CO2 equivalent) in 2000 and Emissions (1000 metric ton of CO2 equivalent) in 2008 in Australia?
Provide a succinct answer. 1.03e+04. What is the difference between the Emissions (1000 metric ton of CO2 equivalent) of 2005 and Emissions (1000 metric ton of CO2 equivalent) of 2008 in Australia?
Your response must be concise. 2570.3. What is the ratio of the Emissions (1000 metric ton of CO2 equivalent) of 1990 in Albania to that in Algeria?
Provide a succinct answer. 0.43. What is the ratio of the Emissions (1000 metric ton of CO2 equivalent) of 2000 in Albania to that in Algeria?
Make the answer very short. 0.26. What is the ratio of the Emissions (1000 metric ton of CO2 equivalent) in 2005 in Albania to that in Algeria?
Offer a very short reply. 0.28. What is the ratio of the Emissions (1000 metric ton of CO2 equivalent) in 2008 in Albania to that in Algeria?
Keep it short and to the point. 0.29. What is the ratio of the Emissions (1000 metric ton of CO2 equivalent) of 1990 in Albania to that in Angola?
Your response must be concise. 0.07. What is the ratio of the Emissions (1000 metric ton of CO2 equivalent) in 2000 in Albania to that in Angola?
Your answer should be compact. 0.28. What is the ratio of the Emissions (1000 metric ton of CO2 equivalent) of 2005 in Albania to that in Angola?
Give a very brief answer. 0.32. What is the ratio of the Emissions (1000 metric ton of CO2 equivalent) in 2008 in Albania to that in Angola?
Provide a succinct answer. 0.33. What is the ratio of the Emissions (1000 metric ton of CO2 equivalent) of 1990 in Albania to that in Argentina?
Make the answer very short. 0.03. What is the ratio of the Emissions (1000 metric ton of CO2 equivalent) in 2000 in Albania to that in Argentina?
Offer a terse response. 0.02. What is the ratio of the Emissions (1000 metric ton of CO2 equivalent) of 2005 in Albania to that in Argentina?
Your answer should be compact. 0.02. What is the ratio of the Emissions (1000 metric ton of CO2 equivalent) in 2008 in Albania to that in Argentina?
Offer a very short reply. 0.02. What is the ratio of the Emissions (1000 metric ton of CO2 equivalent) in 1990 in Albania to that in Armenia?
Your answer should be compact. 1.83. What is the ratio of the Emissions (1000 metric ton of CO2 equivalent) of 2000 in Albania to that in Armenia?
Offer a terse response. 2. What is the ratio of the Emissions (1000 metric ton of CO2 equivalent) in 2005 in Albania to that in Armenia?
Give a very brief answer. 1.72. What is the ratio of the Emissions (1000 metric ton of CO2 equivalent) of 2008 in Albania to that in Armenia?
Offer a very short reply. 1.51. What is the ratio of the Emissions (1000 metric ton of CO2 equivalent) in 1990 in Albania to that in Australia?
Your answer should be very brief. 0.02. What is the ratio of the Emissions (1000 metric ton of CO2 equivalent) in 2000 in Albania to that in Australia?
Offer a terse response. 0.01. What is the ratio of the Emissions (1000 metric ton of CO2 equivalent) of 2005 in Albania to that in Australia?
Give a very brief answer. 0.02. What is the ratio of the Emissions (1000 metric ton of CO2 equivalent) of 2008 in Albania to that in Australia?
Keep it short and to the point. 0.02. What is the ratio of the Emissions (1000 metric ton of CO2 equivalent) of 1990 in Algeria to that in Angola?
Provide a succinct answer. 0.16. What is the ratio of the Emissions (1000 metric ton of CO2 equivalent) in 2000 in Algeria to that in Angola?
Keep it short and to the point. 1.06. What is the ratio of the Emissions (1000 metric ton of CO2 equivalent) of 2005 in Algeria to that in Angola?
Provide a succinct answer. 1.12. What is the ratio of the Emissions (1000 metric ton of CO2 equivalent) in 2008 in Algeria to that in Angola?
Your answer should be compact. 1.14. What is the ratio of the Emissions (1000 metric ton of CO2 equivalent) of 1990 in Algeria to that in Argentina?
Your answer should be very brief. 0.08. What is the ratio of the Emissions (1000 metric ton of CO2 equivalent) in 2000 in Algeria to that in Argentina?
Your answer should be compact. 0.07. What is the ratio of the Emissions (1000 metric ton of CO2 equivalent) of 2005 in Algeria to that in Argentina?
Provide a short and direct response. 0.06. What is the ratio of the Emissions (1000 metric ton of CO2 equivalent) of 2008 in Algeria to that in Argentina?
Your response must be concise. 0.06. What is the ratio of the Emissions (1000 metric ton of CO2 equivalent) in 1990 in Algeria to that in Armenia?
Offer a very short reply. 4.21. What is the ratio of the Emissions (1000 metric ton of CO2 equivalent) in 2000 in Algeria to that in Armenia?
Ensure brevity in your answer.  7.56. What is the ratio of the Emissions (1000 metric ton of CO2 equivalent) in 2005 in Algeria to that in Armenia?
Give a very brief answer. 6.06. What is the ratio of the Emissions (1000 metric ton of CO2 equivalent) of 2008 in Algeria to that in Armenia?
Offer a terse response. 5.12. What is the ratio of the Emissions (1000 metric ton of CO2 equivalent) of 1990 in Algeria to that in Australia?
Make the answer very short. 0.05. What is the ratio of the Emissions (1000 metric ton of CO2 equivalent) of 2000 in Algeria to that in Australia?
Offer a terse response. 0.05. What is the ratio of the Emissions (1000 metric ton of CO2 equivalent) in 2005 in Algeria to that in Australia?
Your response must be concise. 0.06. What is the ratio of the Emissions (1000 metric ton of CO2 equivalent) of 2008 in Algeria to that in Australia?
Your answer should be very brief. 0.07. What is the ratio of the Emissions (1000 metric ton of CO2 equivalent) in 1990 in Angola to that in Argentina?
Make the answer very short. 0.48. What is the ratio of the Emissions (1000 metric ton of CO2 equivalent) of 2000 in Angola to that in Argentina?
Provide a succinct answer. 0.07. What is the ratio of the Emissions (1000 metric ton of CO2 equivalent) in 2005 in Angola to that in Argentina?
Give a very brief answer. 0.06. What is the ratio of the Emissions (1000 metric ton of CO2 equivalent) in 2008 in Angola to that in Argentina?
Your response must be concise. 0.05. What is the ratio of the Emissions (1000 metric ton of CO2 equivalent) in 1990 in Angola to that in Armenia?
Offer a terse response. 26.7. What is the ratio of the Emissions (1000 metric ton of CO2 equivalent) of 2000 in Angola to that in Armenia?
Provide a short and direct response. 7.12. What is the ratio of the Emissions (1000 metric ton of CO2 equivalent) in 2005 in Angola to that in Armenia?
Ensure brevity in your answer.  5.42. What is the ratio of the Emissions (1000 metric ton of CO2 equivalent) in 2008 in Angola to that in Armenia?
Provide a succinct answer. 4.5. What is the ratio of the Emissions (1000 metric ton of CO2 equivalent) in 1990 in Angola to that in Australia?
Provide a succinct answer. 0.31. What is the ratio of the Emissions (1000 metric ton of CO2 equivalent) in 2000 in Angola to that in Australia?
Keep it short and to the point. 0.04. What is the ratio of the Emissions (1000 metric ton of CO2 equivalent) of 2005 in Angola to that in Australia?
Provide a short and direct response. 0.05. What is the ratio of the Emissions (1000 metric ton of CO2 equivalent) of 2008 in Angola to that in Australia?
Provide a succinct answer. 0.06. What is the ratio of the Emissions (1000 metric ton of CO2 equivalent) in 1990 in Argentina to that in Armenia?
Provide a short and direct response. 55.21. What is the ratio of the Emissions (1000 metric ton of CO2 equivalent) of 2000 in Argentina to that in Armenia?
Your answer should be compact. 100.99. What is the ratio of the Emissions (1000 metric ton of CO2 equivalent) of 2005 in Argentina to that in Armenia?
Offer a terse response. 93.85. What is the ratio of the Emissions (1000 metric ton of CO2 equivalent) in 2008 in Argentina to that in Armenia?
Make the answer very short. 82.62. What is the ratio of the Emissions (1000 metric ton of CO2 equivalent) in 1990 in Argentina to that in Australia?
Offer a terse response. 0.64. What is the ratio of the Emissions (1000 metric ton of CO2 equivalent) in 2000 in Argentina to that in Australia?
Your response must be concise. 0.64. What is the ratio of the Emissions (1000 metric ton of CO2 equivalent) of 2005 in Argentina to that in Australia?
Your response must be concise. 0.91. What is the ratio of the Emissions (1000 metric ton of CO2 equivalent) in 2008 in Argentina to that in Australia?
Provide a short and direct response. 1.06. What is the ratio of the Emissions (1000 metric ton of CO2 equivalent) in 1990 in Armenia to that in Australia?
Provide a succinct answer. 0.01. What is the ratio of the Emissions (1000 metric ton of CO2 equivalent) in 2000 in Armenia to that in Australia?
Make the answer very short. 0.01. What is the ratio of the Emissions (1000 metric ton of CO2 equivalent) in 2005 in Armenia to that in Australia?
Offer a terse response. 0.01. What is the ratio of the Emissions (1000 metric ton of CO2 equivalent) of 2008 in Armenia to that in Australia?
Give a very brief answer. 0.01. What is the difference between the highest and the second highest Emissions (1000 metric ton of CO2 equivalent) in 1990?
Your response must be concise. 1.80e+04. What is the difference between the highest and the second highest Emissions (1000 metric ton of CO2 equivalent) of 2000?
Provide a succinct answer. 2.06e+04. What is the difference between the highest and the second highest Emissions (1000 metric ton of CO2 equivalent) of 2005?
Provide a succinct answer. 4485.6. What is the difference between the highest and the second highest Emissions (1000 metric ton of CO2 equivalent) in 2008?
Ensure brevity in your answer.  2702.4. What is the difference between the highest and the lowest Emissions (1000 metric ton of CO2 equivalent) in 1990?
Your answer should be compact. 4.98e+04. What is the difference between the highest and the lowest Emissions (1000 metric ton of CO2 equivalent) of 2000?
Provide a succinct answer. 5.62e+04. What is the difference between the highest and the lowest Emissions (1000 metric ton of CO2 equivalent) in 2005?
Give a very brief answer. 4.84e+04. What is the difference between the highest and the lowest Emissions (1000 metric ton of CO2 equivalent) of 2008?
Your answer should be compact. 4.84e+04. 